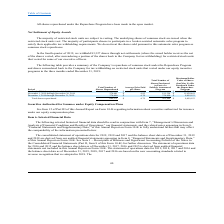From Mobileiron's financial document, What is the Maximum Dollar Value of shares that may yet be purchased under the Repurchase Program during October 1, 2019 through October 31, 2019 and during November 1, 2019 through November 30, 2019 respectively? The document shows two values: 12,544,543 and 11,620,641. From the document: "ctober 1, 2019 through October 31, 2019 — $ — — $ 12,544,543 hrough November 30, 2019 274,681 $ 4.82 191,354 $ 11,620,641..." Also, What is the total number of shares repurchased for December 1, 2019 through December 31, 2019 and for November 1, 2019 through November 30, 2019 respectively? The document shows two values: 374,490 and 274,681. From the document: "December 1, 2019 through December 31, 2019 374,490 $ 4.70 374,490 $ 9,859,153 November 1, 2019 through November 30, 2019 274,681 $ 4.82 191,354 $ 11,6..." Also, When are the underlying shares of common stock issued? when the restricted stock units vest.. The document states: ". The underlying shares of common stock are issued when the restricted stock units vest. The majority of participants choose to participate in a broke..." Also, can you calculate: What is the total Maximum Dollar Value of shares that may yet be purchased under the Repurchase Program during October 1, 2019 through November 30, 2019? Based on the calculation: 12,544,543+11,620,641, the result is 24165184. This is based on the information: "ctober 1, 2019 through October 31, 2019 — $ — — $ 12,544,543 hrough November 30, 2019 274,681 $ 4.82 191,354 $ 11,620,641..." The key data points involved are: 11,620,641, 12,544,543. Also, can you calculate: What is the percentage change in total Number of Shares Purchased as part of a Publicly Announced Program from November to December 2019? To answer this question, I need to perform calculations using the financial data. The calculation is: (374,490-191,354)/191,354, which equals 95.71 (percentage). This is based on the information: "December 1, 2019 through December 31, 2019 374,490 $ 4.70 374,490 $ 9,859,153 1, 2019 through November 30, 2019 274,681 $ 4.82 191,354 $ 11,620,641..." The key data points involved are: 191,354, 374,490. Also, From November 1 2019 to December 31 2019, how many months was the average price paid per share more than $4.72? Based on the analysis, there are 1 instances. The counting process: November. 